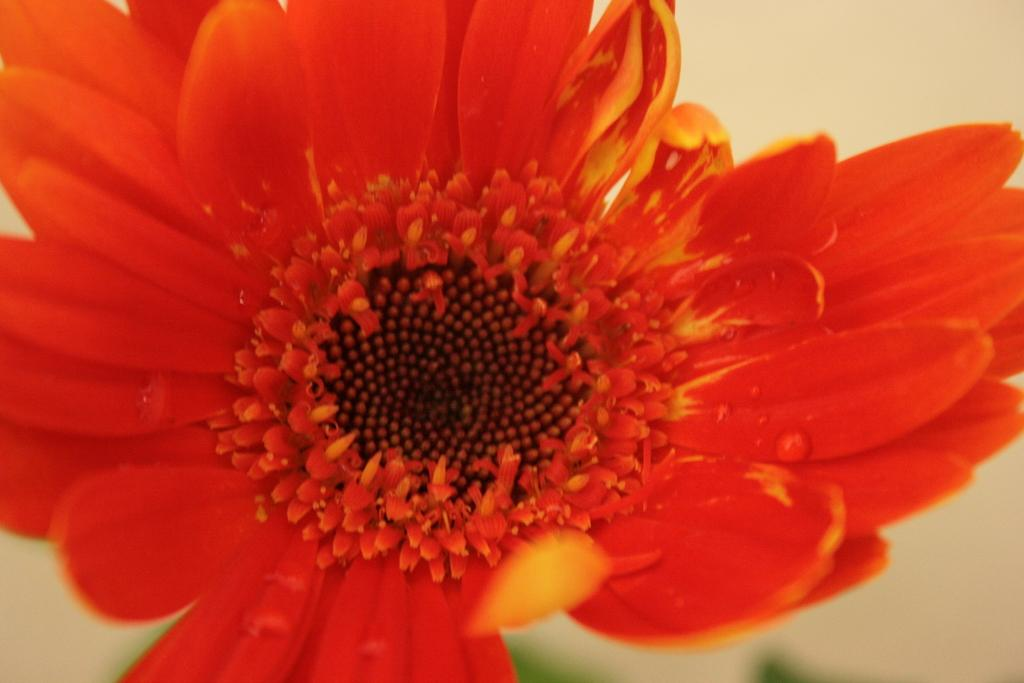What is the main subject in the center of the image? There is a flower in the center of the image. What color is the flower in the image? The flower is red in color. What type of neck accessory is the flower wearing in the image? The flower is not wearing any neck accessory in the image, as it is a plant and not a person. What type of shoes can be seen on the flower in the image? The flower is not wearing any shoes in the image, as it is a plant and not a person. 